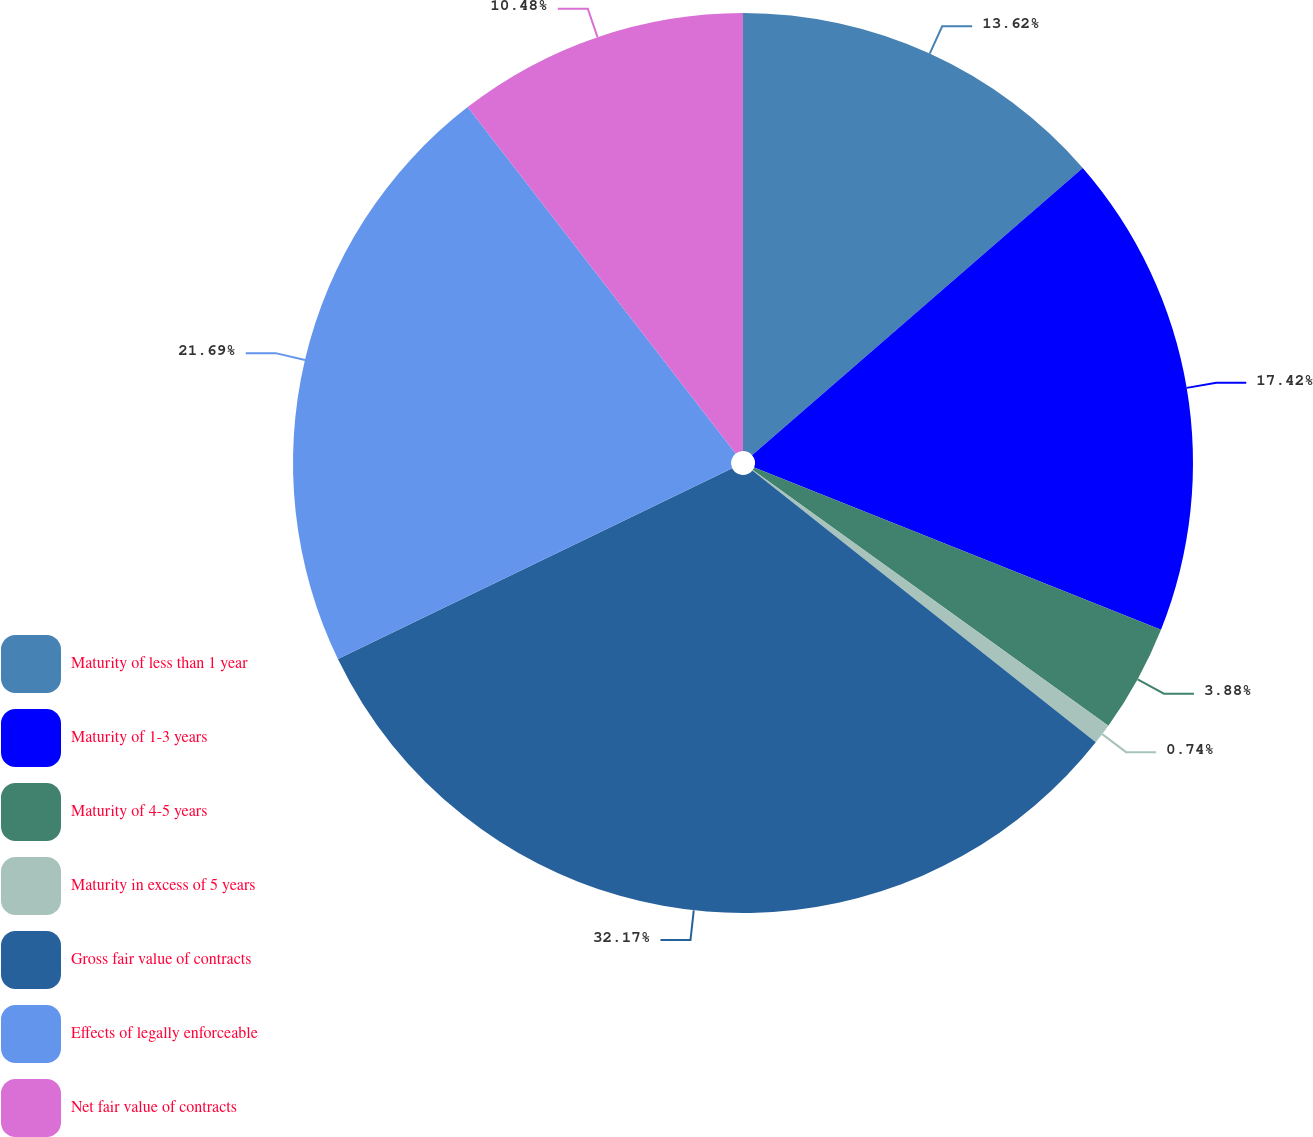Convert chart to OTSL. <chart><loc_0><loc_0><loc_500><loc_500><pie_chart><fcel>Maturity of less than 1 year<fcel>Maturity of 1-3 years<fcel>Maturity of 4-5 years<fcel>Maturity in excess of 5 years<fcel>Gross fair value of contracts<fcel>Effects of legally enforceable<fcel>Net fair value of contracts<nl><fcel>13.62%<fcel>17.42%<fcel>3.88%<fcel>0.74%<fcel>32.17%<fcel>21.69%<fcel>10.48%<nl></chart> 